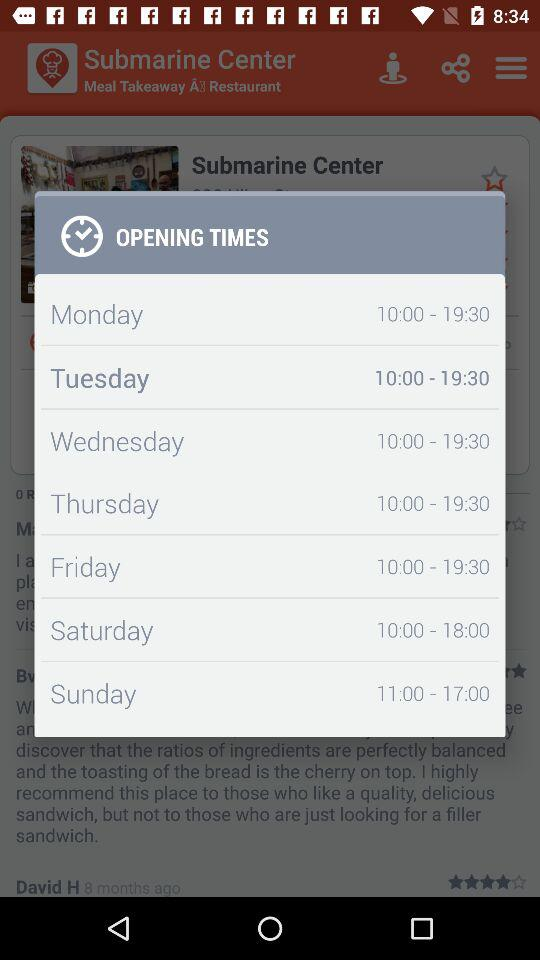How many hours does the store open on Monday?
Answer the question using a single word or phrase. 9.5 